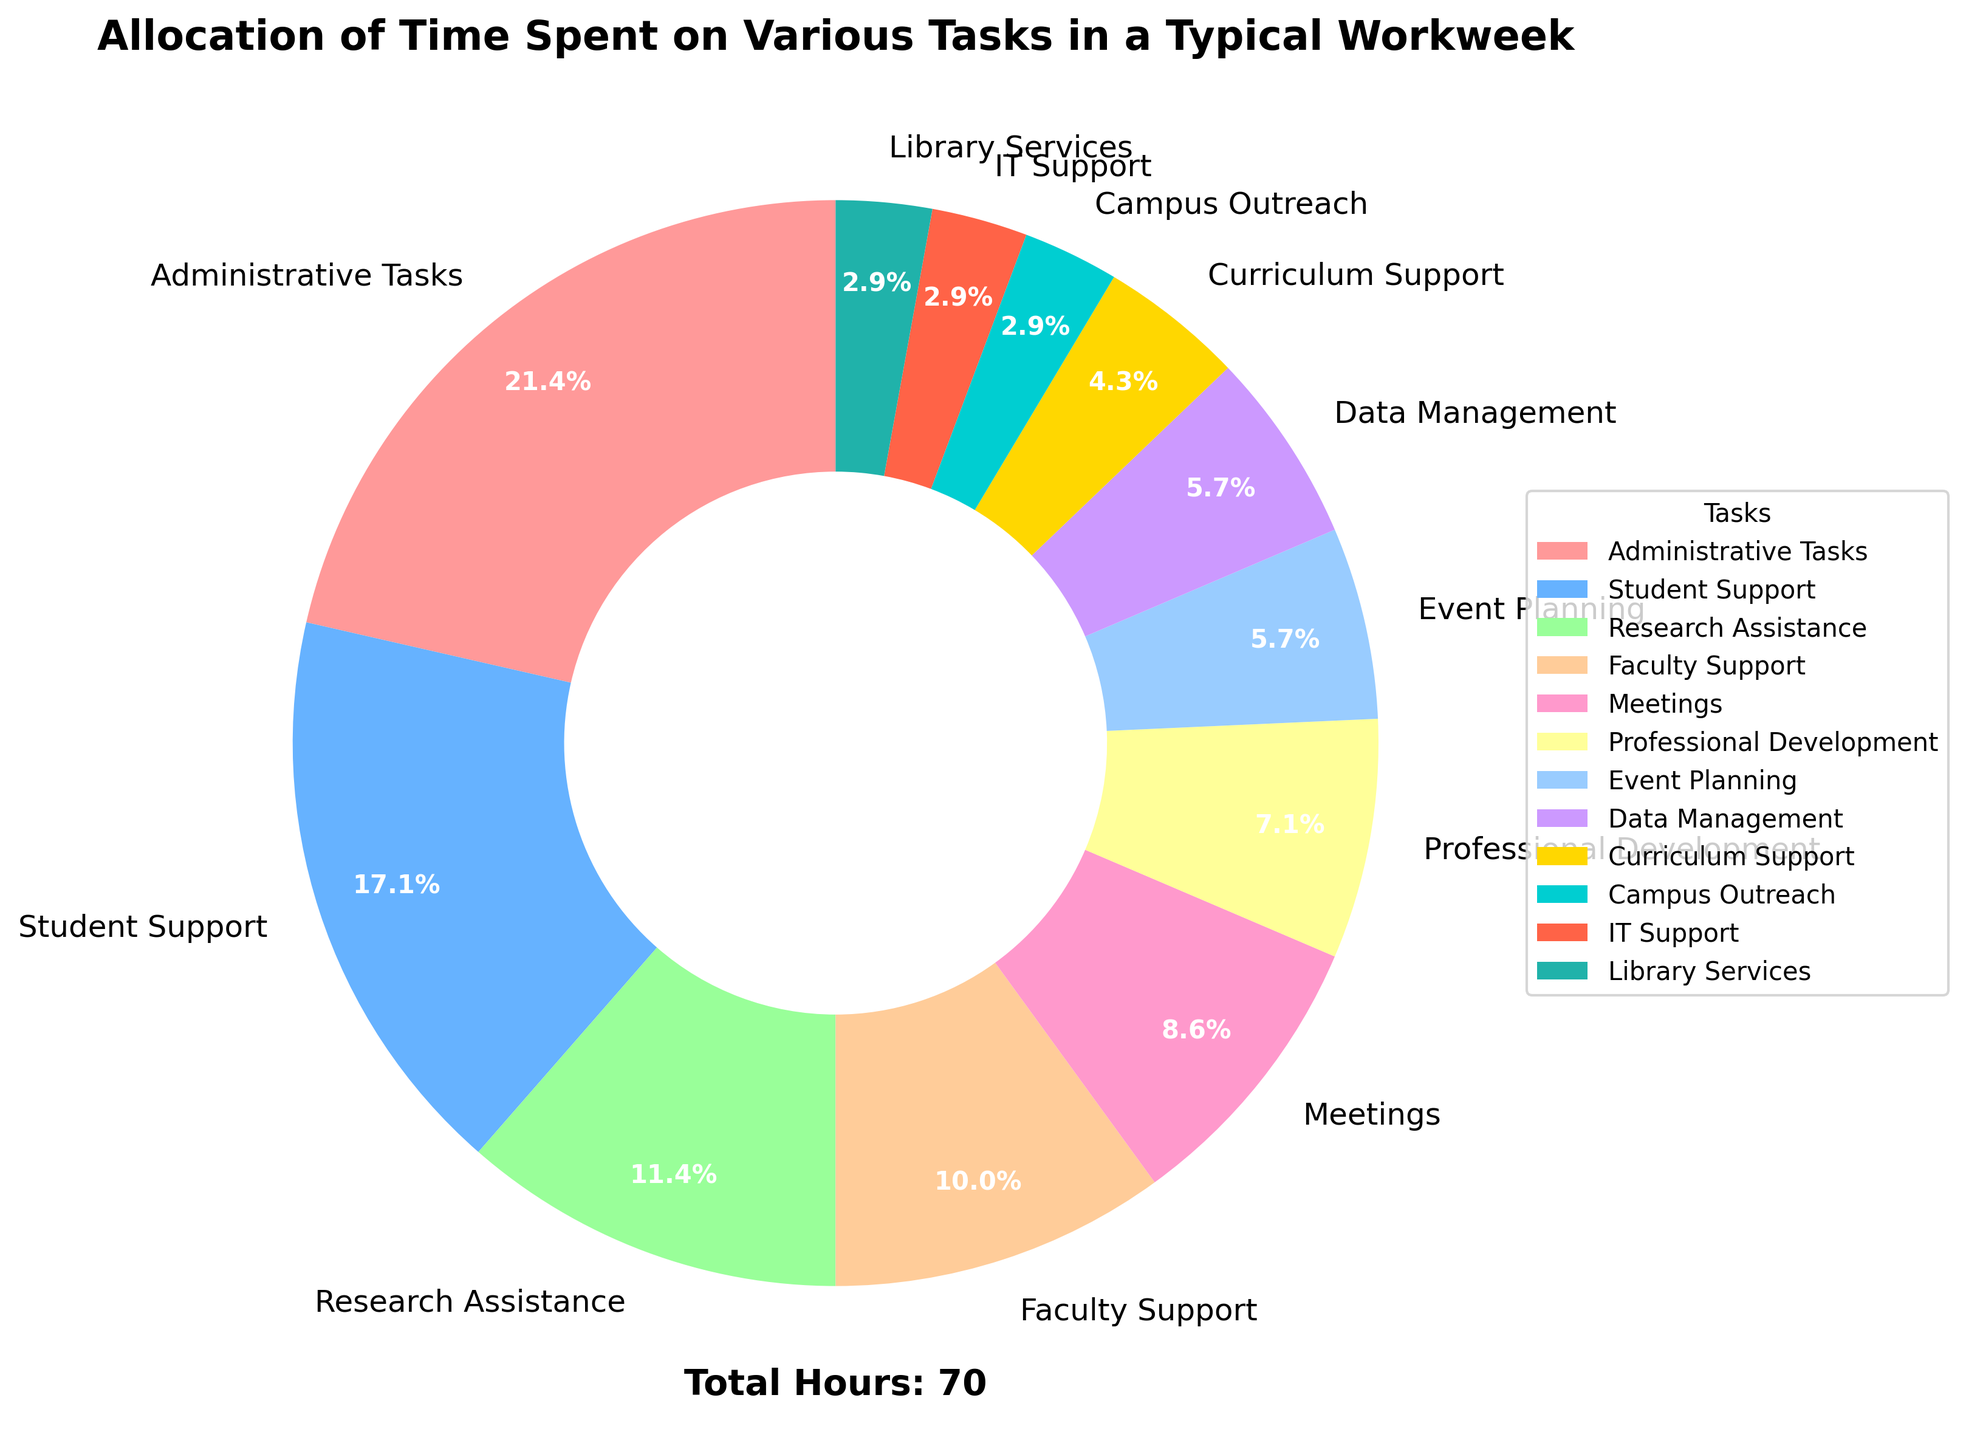What percentage of time is spent on Administrative Tasks? Look at the segment labeled "Administrative Tasks" on the pie chart and read the percentage displayed on it.
Answer: 24.6% Which task has the second highest allocation of time? Examine the pie chart and identify the task with the second largest segment after "Administrative Tasks."
Answer: Student Support How much total time is spent on Meetings and Event Planning combined? Check the hours dedicated to Meetings (6 hours) and Event Planning (4 hours), then add them. 6 + 4 = 10
Answer: 10 hours Which tasks are allocated exactly 2% of the time each? Look at the pie chart for segments labeled with "2%" and identify the corresponding tasks.
Answer: Campus Outreach, IT Support, Library Services Compare the time spent on Research Assistance and Faculty Support. Which one has more hours allocated? Find the segments representing "Research Assistance" and "Faculty Support" and compare their values. Research Assistance: 8 hours, Faculty Support: 7 hours.
Answer: Research Assistance What is the total percentage of time spent on tasks labeled with a percentage that is less than 5%? Identify all the segments with a percentage less than 5%: Event Planning (4%), Data Management (4%), Curriculum Support (3%), Campus Outreach (2%), IT Support (2%), Library Services (2%). Sum their percentages: 4% + 4% + 3% + 2% + 2% + 2% = 17%
Answer: 17% Which color represents the "Professional Development" segment? Look at the legend next to the pie chart and identify the color corresponding to the "Professional Development" label.
Answer: Yellow If Administrative Tasks and Student Support were combined into a single task, what would be the new percentage allocation for this combined task? Sum the hours spent on Administrative Tasks (15 hours) and Student Support (12 hours) to get the total hours (15 + 12 = 27). Then, calculate the percentage of these 27 hours out of the total hours (66 hours): (27 / 66) * 100 ≈ 40.9%
Answer: 40.9% 